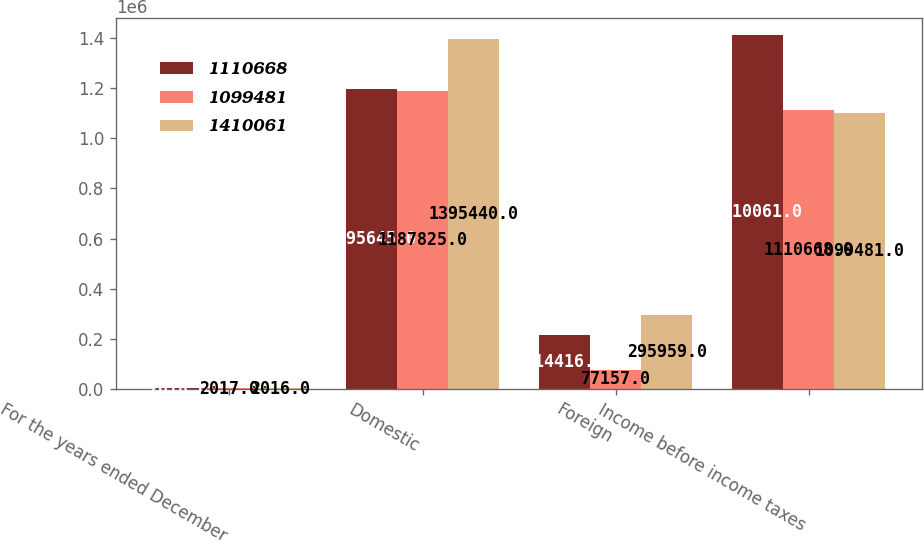Convert chart. <chart><loc_0><loc_0><loc_500><loc_500><stacked_bar_chart><ecel><fcel>For the years ended December<fcel>Domestic<fcel>Foreign<fcel>Income before income taxes<nl><fcel>1.11067e+06<fcel>2018<fcel>1.19564e+06<fcel>214416<fcel>1.41006e+06<nl><fcel>1.09948e+06<fcel>2017<fcel>1.18782e+06<fcel>77157<fcel>1.11067e+06<nl><fcel>1.41006e+06<fcel>2016<fcel>1.39544e+06<fcel>295959<fcel>1.09948e+06<nl></chart> 